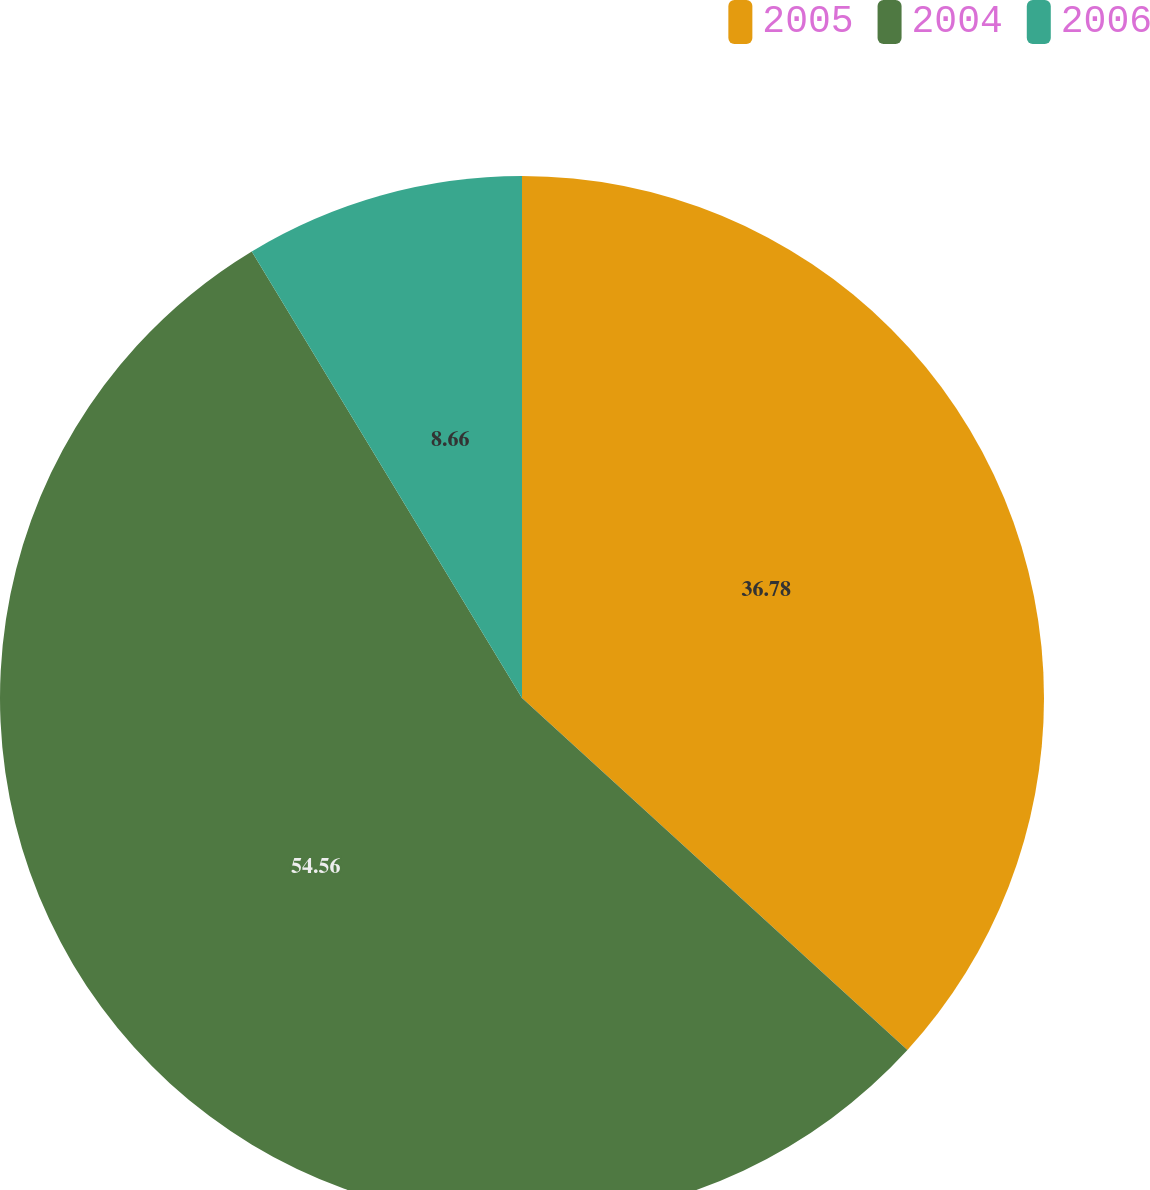Convert chart to OTSL. <chart><loc_0><loc_0><loc_500><loc_500><pie_chart><fcel>2005<fcel>2004<fcel>2006<nl><fcel>36.78%<fcel>54.56%<fcel>8.66%<nl></chart> 